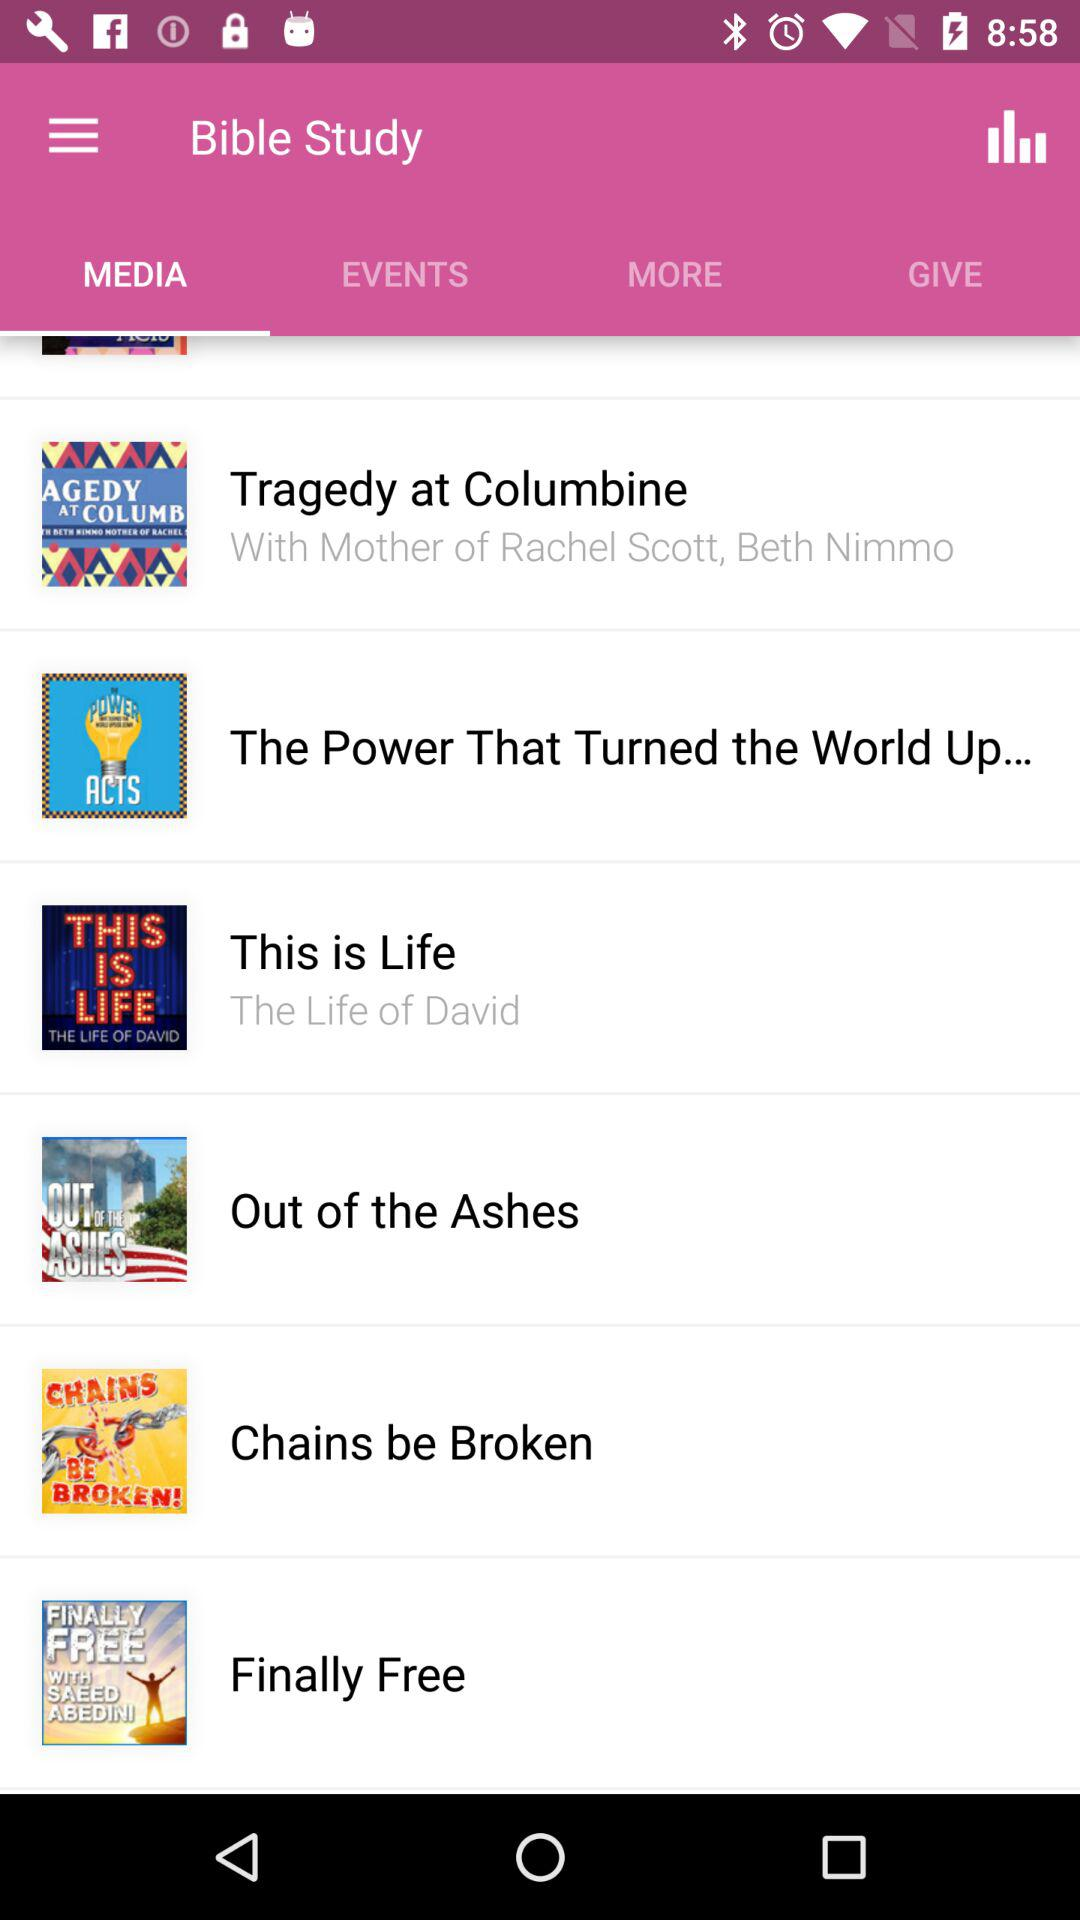Which tab is open? The open tab is "Media". 